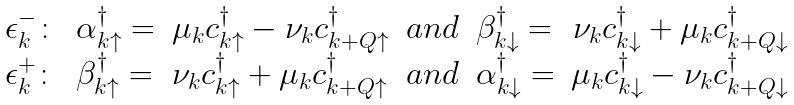Convert formula to latex. <formula><loc_0><loc_0><loc_500><loc_500>\begin{array} { l l l l l r } \epsilon _ { k } ^ { - } \colon & \alpha ^ { \dagger } _ { k \uparrow } = & \mu _ { k } c ^ { \dagger } _ { k \uparrow } - \nu _ { k } c ^ { \dagger } _ { k + Q \uparrow } & a n d & \beta ^ { \dagger } _ { k \downarrow } = & \nu _ { k } c ^ { \dagger } _ { k \downarrow } + \mu _ { k } c ^ { \dagger } _ { k + Q \downarrow } \\ \epsilon _ { k } ^ { + } \colon & \beta ^ { \dagger } _ { k \uparrow } = & \nu _ { k } c ^ { \dagger } _ { k \uparrow } + \mu _ { k } c ^ { \dagger } _ { k + Q \uparrow } & a n d & \alpha ^ { \dagger } _ { k \downarrow } = & \mu _ { k } c ^ { \dagger } _ { k \downarrow } - \nu _ { k } c ^ { \dagger } _ { k + Q \downarrow } \\ \end{array}</formula> 